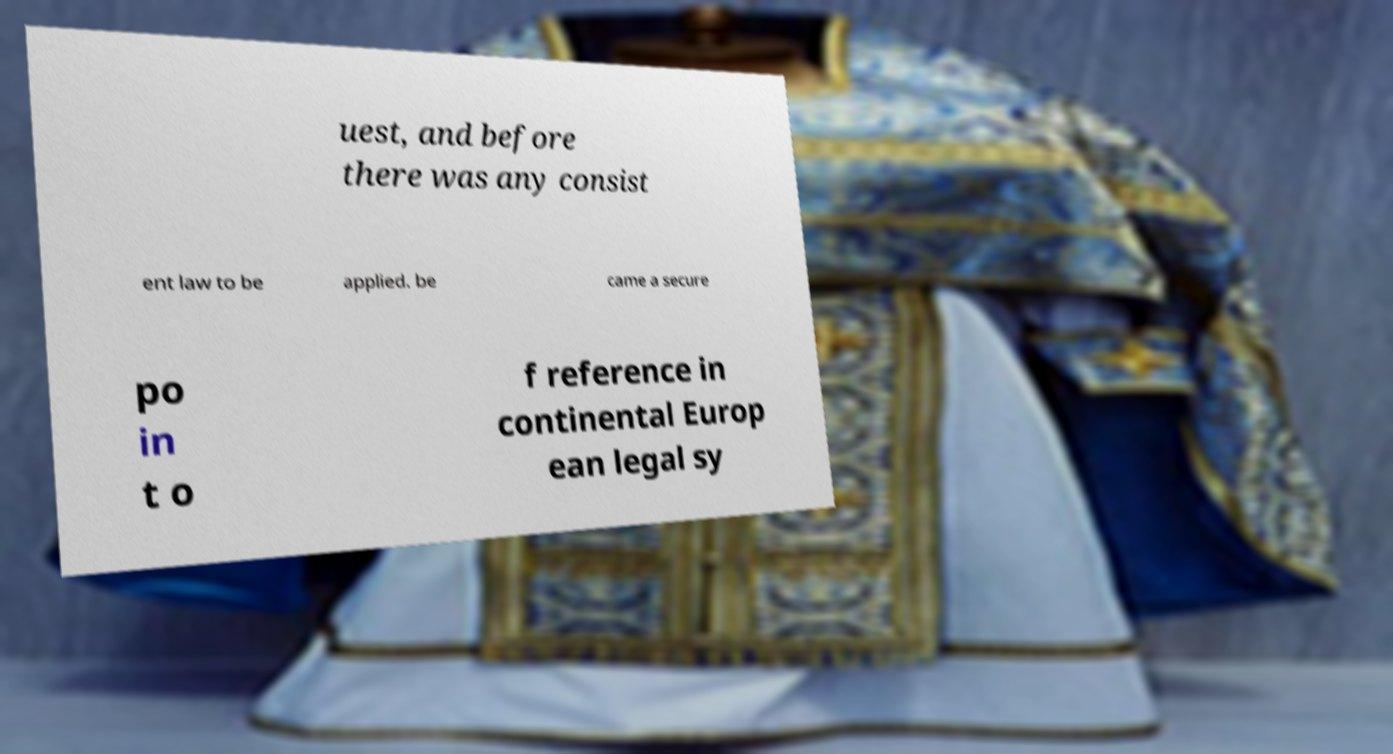Can you read and provide the text displayed in the image?This photo seems to have some interesting text. Can you extract and type it out for me? uest, and before there was any consist ent law to be applied. be came a secure po in t o f reference in continental Europ ean legal sy 